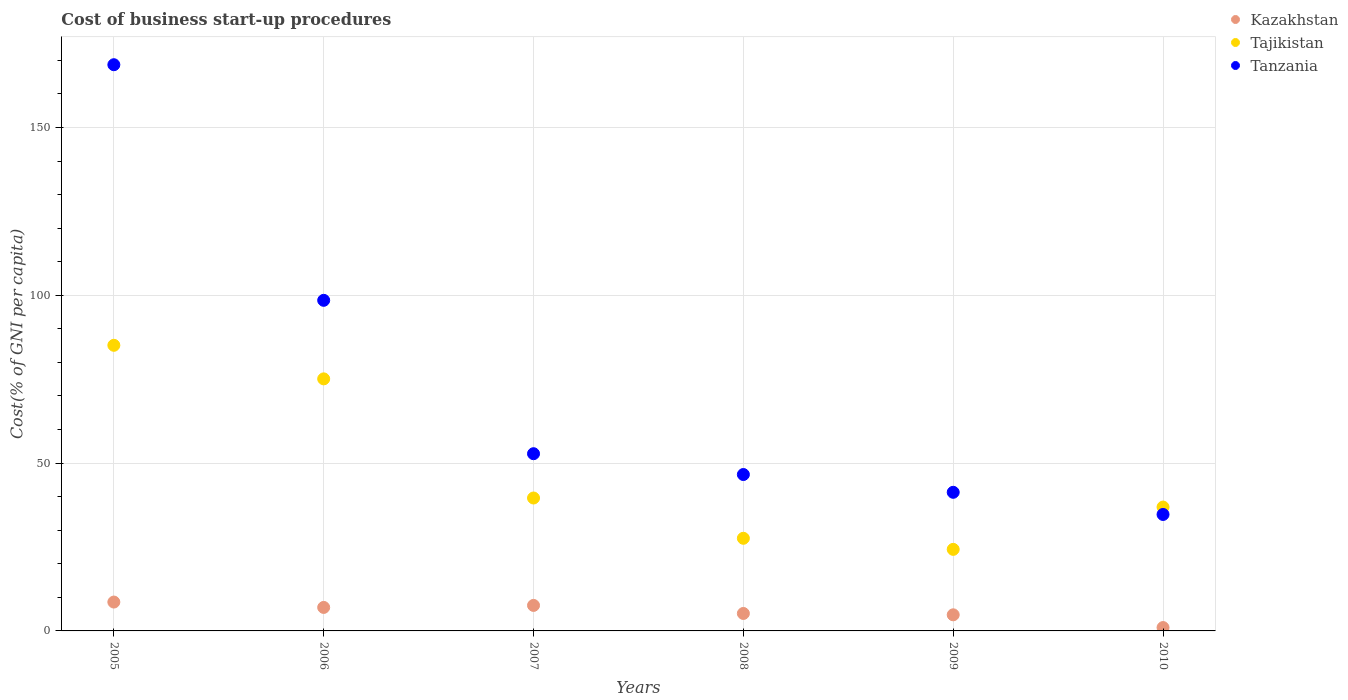Is the number of dotlines equal to the number of legend labels?
Ensure brevity in your answer.  Yes. What is the cost of business start-up procedures in Tajikistan in 2008?
Offer a very short reply. 27.6. Across all years, what is the maximum cost of business start-up procedures in Kazakhstan?
Keep it short and to the point. 8.6. Across all years, what is the minimum cost of business start-up procedures in Kazakhstan?
Your answer should be very brief. 1. In which year was the cost of business start-up procedures in Tanzania maximum?
Provide a succinct answer. 2005. In which year was the cost of business start-up procedures in Kazakhstan minimum?
Offer a terse response. 2010. What is the total cost of business start-up procedures in Tajikistan in the graph?
Your response must be concise. 288.6. What is the difference between the cost of business start-up procedures in Tanzania in 2005 and that in 2007?
Make the answer very short. 115.9. What is the difference between the cost of business start-up procedures in Tanzania in 2006 and the cost of business start-up procedures in Kazakhstan in 2010?
Ensure brevity in your answer.  97.5. What is the average cost of business start-up procedures in Tajikistan per year?
Provide a succinct answer. 48.1. In the year 2006, what is the difference between the cost of business start-up procedures in Tanzania and cost of business start-up procedures in Tajikistan?
Make the answer very short. 23.4. In how many years, is the cost of business start-up procedures in Kazakhstan greater than 50 %?
Your answer should be compact. 0. Is the cost of business start-up procedures in Tajikistan in 2006 less than that in 2009?
Your response must be concise. No. What is the difference between the highest and the second highest cost of business start-up procedures in Tanzania?
Your answer should be compact. 70.2. What is the difference between the highest and the lowest cost of business start-up procedures in Tanzania?
Your response must be concise. 134. Is the sum of the cost of business start-up procedures in Tajikistan in 2008 and 2009 greater than the maximum cost of business start-up procedures in Kazakhstan across all years?
Your answer should be compact. Yes. Is it the case that in every year, the sum of the cost of business start-up procedures in Kazakhstan and cost of business start-up procedures in Tanzania  is greater than the cost of business start-up procedures in Tajikistan?
Make the answer very short. No. Does the cost of business start-up procedures in Tanzania monotonically increase over the years?
Your response must be concise. No. Is the cost of business start-up procedures in Tajikistan strictly less than the cost of business start-up procedures in Tanzania over the years?
Provide a short and direct response. No. How many years are there in the graph?
Offer a very short reply. 6. Does the graph contain grids?
Make the answer very short. Yes. Where does the legend appear in the graph?
Make the answer very short. Top right. How many legend labels are there?
Make the answer very short. 3. How are the legend labels stacked?
Keep it short and to the point. Vertical. What is the title of the graph?
Make the answer very short. Cost of business start-up procedures. Does "East Asia (all income levels)" appear as one of the legend labels in the graph?
Your response must be concise. No. What is the label or title of the X-axis?
Give a very brief answer. Years. What is the label or title of the Y-axis?
Ensure brevity in your answer.  Cost(% of GNI per capita). What is the Cost(% of GNI per capita) of Tajikistan in 2005?
Make the answer very short. 85.1. What is the Cost(% of GNI per capita) of Tanzania in 2005?
Your answer should be very brief. 168.7. What is the Cost(% of GNI per capita) of Kazakhstan in 2006?
Your answer should be compact. 7. What is the Cost(% of GNI per capita) of Tajikistan in 2006?
Make the answer very short. 75.1. What is the Cost(% of GNI per capita) of Tanzania in 2006?
Keep it short and to the point. 98.5. What is the Cost(% of GNI per capita) in Kazakhstan in 2007?
Offer a terse response. 7.6. What is the Cost(% of GNI per capita) of Tajikistan in 2007?
Your response must be concise. 39.6. What is the Cost(% of GNI per capita) in Tanzania in 2007?
Provide a short and direct response. 52.8. What is the Cost(% of GNI per capita) in Kazakhstan in 2008?
Your answer should be very brief. 5.2. What is the Cost(% of GNI per capita) of Tajikistan in 2008?
Give a very brief answer. 27.6. What is the Cost(% of GNI per capita) in Tanzania in 2008?
Offer a very short reply. 46.6. What is the Cost(% of GNI per capita) in Tajikistan in 2009?
Offer a very short reply. 24.3. What is the Cost(% of GNI per capita) in Tanzania in 2009?
Keep it short and to the point. 41.3. What is the Cost(% of GNI per capita) of Tajikistan in 2010?
Offer a very short reply. 36.9. What is the Cost(% of GNI per capita) of Tanzania in 2010?
Provide a short and direct response. 34.7. Across all years, what is the maximum Cost(% of GNI per capita) of Tajikistan?
Keep it short and to the point. 85.1. Across all years, what is the maximum Cost(% of GNI per capita) of Tanzania?
Your response must be concise. 168.7. Across all years, what is the minimum Cost(% of GNI per capita) of Kazakhstan?
Provide a short and direct response. 1. Across all years, what is the minimum Cost(% of GNI per capita) of Tajikistan?
Provide a succinct answer. 24.3. Across all years, what is the minimum Cost(% of GNI per capita) of Tanzania?
Ensure brevity in your answer.  34.7. What is the total Cost(% of GNI per capita) of Kazakhstan in the graph?
Provide a short and direct response. 34.2. What is the total Cost(% of GNI per capita) of Tajikistan in the graph?
Ensure brevity in your answer.  288.6. What is the total Cost(% of GNI per capita) in Tanzania in the graph?
Ensure brevity in your answer.  442.6. What is the difference between the Cost(% of GNI per capita) of Tajikistan in 2005 and that in 2006?
Give a very brief answer. 10. What is the difference between the Cost(% of GNI per capita) in Tanzania in 2005 and that in 2006?
Provide a succinct answer. 70.2. What is the difference between the Cost(% of GNI per capita) in Tajikistan in 2005 and that in 2007?
Give a very brief answer. 45.5. What is the difference between the Cost(% of GNI per capita) of Tanzania in 2005 and that in 2007?
Provide a short and direct response. 115.9. What is the difference between the Cost(% of GNI per capita) in Kazakhstan in 2005 and that in 2008?
Keep it short and to the point. 3.4. What is the difference between the Cost(% of GNI per capita) of Tajikistan in 2005 and that in 2008?
Your answer should be very brief. 57.5. What is the difference between the Cost(% of GNI per capita) in Tanzania in 2005 and that in 2008?
Your answer should be very brief. 122.1. What is the difference between the Cost(% of GNI per capita) of Kazakhstan in 2005 and that in 2009?
Provide a short and direct response. 3.8. What is the difference between the Cost(% of GNI per capita) in Tajikistan in 2005 and that in 2009?
Provide a short and direct response. 60.8. What is the difference between the Cost(% of GNI per capita) of Tanzania in 2005 and that in 2009?
Your response must be concise. 127.4. What is the difference between the Cost(% of GNI per capita) in Kazakhstan in 2005 and that in 2010?
Your answer should be very brief. 7.6. What is the difference between the Cost(% of GNI per capita) in Tajikistan in 2005 and that in 2010?
Provide a short and direct response. 48.2. What is the difference between the Cost(% of GNI per capita) in Tanzania in 2005 and that in 2010?
Your answer should be very brief. 134. What is the difference between the Cost(% of GNI per capita) in Kazakhstan in 2006 and that in 2007?
Your answer should be very brief. -0.6. What is the difference between the Cost(% of GNI per capita) in Tajikistan in 2006 and that in 2007?
Your answer should be very brief. 35.5. What is the difference between the Cost(% of GNI per capita) of Tanzania in 2006 and that in 2007?
Offer a terse response. 45.7. What is the difference between the Cost(% of GNI per capita) in Kazakhstan in 2006 and that in 2008?
Your answer should be compact. 1.8. What is the difference between the Cost(% of GNI per capita) in Tajikistan in 2006 and that in 2008?
Your answer should be very brief. 47.5. What is the difference between the Cost(% of GNI per capita) in Tanzania in 2006 and that in 2008?
Keep it short and to the point. 51.9. What is the difference between the Cost(% of GNI per capita) of Kazakhstan in 2006 and that in 2009?
Offer a terse response. 2.2. What is the difference between the Cost(% of GNI per capita) in Tajikistan in 2006 and that in 2009?
Offer a very short reply. 50.8. What is the difference between the Cost(% of GNI per capita) in Tanzania in 2006 and that in 2009?
Keep it short and to the point. 57.2. What is the difference between the Cost(% of GNI per capita) of Tajikistan in 2006 and that in 2010?
Your response must be concise. 38.2. What is the difference between the Cost(% of GNI per capita) of Tanzania in 2006 and that in 2010?
Your response must be concise. 63.8. What is the difference between the Cost(% of GNI per capita) in Tajikistan in 2007 and that in 2008?
Keep it short and to the point. 12. What is the difference between the Cost(% of GNI per capita) of Tanzania in 2007 and that in 2008?
Offer a very short reply. 6.2. What is the difference between the Cost(% of GNI per capita) in Kazakhstan in 2007 and that in 2009?
Provide a short and direct response. 2.8. What is the difference between the Cost(% of GNI per capita) of Tajikistan in 2007 and that in 2009?
Make the answer very short. 15.3. What is the difference between the Cost(% of GNI per capita) of Tanzania in 2007 and that in 2010?
Offer a very short reply. 18.1. What is the difference between the Cost(% of GNI per capita) in Kazakhstan in 2008 and that in 2009?
Offer a very short reply. 0.4. What is the difference between the Cost(% of GNI per capita) of Tanzania in 2008 and that in 2009?
Ensure brevity in your answer.  5.3. What is the difference between the Cost(% of GNI per capita) in Kazakhstan in 2008 and that in 2010?
Offer a terse response. 4.2. What is the difference between the Cost(% of GNI per capita) in Tanzania in 2008 and that in 2010?
Give a very brief answer. 11.9. What is the difference between the Cost(% of GNI per capita) of Tajikistan in 2009 and that in 2010?
Provide a succinct answer. -12.6. What is the difference between the Cost(% of GNI per capita) of Tanzania in 2009 and that in 2010?
Offer a very short reply. 6.6. What is the difference between the Cost(% of GNI per capita) in Kazakhstan in 2005 and the Cost(% of GNI per capita) in Tajikistan in 2006?
Ensure brevity in your answer.  -66.5. What is the difference between the Cost(% of GNI per capita) in Kazakhstan in 2005 and the Cost(% of GNI per capita) in Tanzania in 2006?
Provide a succinct answer. -89.9. What is the difference between the Cost(% of GNI per capita) in Tajikistan in 2005 and the Cost(% of GNI per capita) in Tanzania in 2006?
Your answer should be very brief. -13.4. What is the difference between the Cost(% of GNI per capita) in Kazakhstan in 2005 and the Cost(% of GNI per capita) in Tajikistan in 2007?
Offer a very short reply. -31. What is the difference between the Cost(% of GNI per capita) in Kazakhstan in 2005 and the Cost(% of GNI per capita) in Tanzania in 2007?
Provide a short and direct response. -44.2. What is the difference between the Cost(% of GNI per capita) of Tajikistan in 2005 and the Cost(% of GNI per capita) of Tanzania in 2007?
Your answer should be very brief. 32.3. What is the difference between the Cost(% of GNI per capita) of Kazakhstan in 2005 and the Cost(% of GNI per capita) of Tajikistan in 2008?
Your answer should be very brief. -19. What is the difference between the Cost(% of GNI per capita) of Kazakhstan in 2005 and the Cost(% of GNI per capita) of Tanzania in 2008?
Keep it short and to the point. -38. What is the difference between the Cost(% of GNI per capita) of Tajikistan in 2005 and the Cost(% of GNI per capita) of Tanzania in 2008?
Give a very brief answer. 38.5. What is the difference between the Cost(% of GNI per capita) of Kazakhstan in 2005 and the Cost(% of GNI per capita) of Tajikistan in 2009?
Your answer should be very brief. -15.7. What is the difference between the Cost(% of GNI per capita) of Kazakhstan in 2005 and the Cost(% of GNI per capita) of Tanzania in 2009?
Your answer should be compact. -32.7. What is the difference between the Cost(% of GNI per capita) in Tajikistan in 2005 and the Cost(% of GNI per capita) in Tanzania in 2009?
Offer a terse response. 43.8. What is the difference between the Cost(% of GNI per capita) of Kazakhstan in 2005 and the Cost(% of GNI per capita) of Tajikistan in 2010?
Provide a short and direct response. -28.3. What is the difference between the Cost(% of GNI per capita) of Kazakhstan in 2005 and the Cost(% of GNI per capita) of Tanzania in 2010?
Keep it short and to the point. -26.1. What is the difference between the Cost(% of GNI per capita) of Tajikistan in 2005 and the Cost(% of GNI per capita) of Tanzania in 2010?
Your response must be concise. 50.4. What is the difference between the Cost(% of GNI per capita) of Kazakhstan in 2006 and the Cost(% of GNI per capita) of Tajikistan in 2007?
Provide a short and direct response. -32.6. What is the difference between the Cost(% of GNI per capita) of Kazakhstan in 2006 and the Cost(% of GNI per capita) of Tanzania in 2007?
Give a very brief answer. -45.8. What is the difference between the Cost(% of GNI per capita) of Tajikistan in 2006 and the Cost(% of GNI per capita) of Tanzania in 2007?
Give a very brief answer. 22.3. What is the difference between the Cost(% of GNI per capita) of Kazakhstan in 2006 and the Cost(% of GNI per capita) of Tajikistan in 2008?
Ensure brevity in your answer.  -20.6. What is the difference between the Cost(% of GNI per capita) of Kazakhstan in 2006 and the Cost(% of GNI per capita) of Tanzania in 2008?
Give a very brief answer. -39.6. What is the difference between the Cost(% of GNI per capita) in Tajikistan in 2006 and the Cost(% of GNI per capita) in Tanzania in 2008?
Your answer should be very brief. 28.5. What is the difference between the Cost(% of GNI per capita) in Kazakhstan in 2006 and the Cost(% of GNI per capita) in Tajikistan in 2009?
Offer a very short reply. -17.3. What is the difference between the Cost(% of GNI per capita) in Kazakhstan in 2006 and the Cost(% of GNI per capita) in Tanzania in 2009?
Your response must be concise. -34.3. What is the difference between the Cost(% of GNI per capita) of Tajikistan in 2006 and the Cost(% of GNI per capita) of Tanzania in 2009?
Keep it short and to the point. 33.8. What is the difference between the Cost(% of GNI per capita) in Kazakhstan in 2006 and the Cost(% of GNI per capita) in Tajikistan in 2010?
Your response must be concise. -29.9. What is the difference between the Cost(% of GNI per capita) in Kazakhstan in 2006 and the Cost(% of GNI per capita) in Tanzania in 2010?
Ensure brevity in your answer.  -27.7. What is the difference between the Cost(% of GNI per capita) of Tajikistan in 2006 and the Cost(% of GNI per capita) of Tanzania in 2010?
Provide a short and direct response. 40.4. What is the difference between the Cost(% of GNI per capita) in Kazakhstan in 2007 and the Cost(% of GNI per capita) in Tajikistan in 2008?
Provide a succinct answer. -20. What is the difference between the Cost(% of GNI per capita) in Kazakhstan in 2007 and the Cost(% of GNI per capita) in Tanzania in 2008?
Your response must be concise. -39. What is the difference between the Cost(% of GNI per capita) in Kazakhstan in 2007 and the Cost(% of GNI per capita) in Tajikistan in 2009?
Your answer should be very brief. -16.7. What is the difference between the Cost(% of GNI per capita) of Kazakhstan in 2007 and the Cost(% of GNI per capita) of Tanzania in 2009?
Give a very brief answer. -33.7. What is the difference between the Cost(% of GNI per capita) in Tajikistan in 2007 and the Cost(% of GNI per capita) in Tanzania in 2009?
Your response must be concise. -1.7. What is the difference between the Cost(% of GNI per capita) of Kazakhstan in 2007 and the Cost(% of GNI per capita) of Tajikistan in 2010?
Keep it short and to the point. -29.3. What is the difference between the Cost(% of GNI per capita) of Kazakhstan in 2007 and the Cost(% of GNI per capita) of Tanzania in 2010?
Keep it short and to the point. -27.1. What is the difference between the Cost(% of GNI per capita) of Tajikistan in 2007 and the Cost(% of GNI per capita) of Tanzania in 2010?
Make the answer very short. 4.9. What is the difference between the Cost(% of GNI per capita) in Kazakhstan in 2008 and the Cost(% of GNI per capita) in Tajikistan in 2009?
Your answer should be compact. -19.1. What is the difference between the Cost(% of GNI per capita) of Kazakhstan in 2008 and the Cost(% of GNI per capita) of Tanzania in 2009?
Your answer should be very brief. -36.1. What is the difference between the Cost(% of GNI per capita) in Tajikistan in 2008 and the Cost(% of GNI per capita) in Tanzania in 2009?
Offer a terse response. -13.7. What is the difference between the Cost(% of GNI per capita) in Kazakhstan in 2008 and the Cost(% of GNI per capita) in Tajikistan in 2010?
Ensure brevity in your answer.  -31.7. What is the difference between the Cost(% of GNI per capita) in Kazakhstan in 2008 and the Cost(% of GNI per capita) in Tanzania in 2010?
Offer a terse response. -29.5. What is the difference between the Cost(% of GNI per capita) in Kazakhstan in 2009 and the Cost(% of GNI per capita) in Tajikistan in 2010?
Ensure brevity in your answer.  -32.1. What is the difference between the Cost(% of GNI per capita) of Kazakhstan in 2009 and the Cost(% of GNI per capita) of Tanzania in 2010?
Give a very brief answer. -29.9. What is the difference between the Cost(% of GNI per capita) of Tajikistan in 2009 and the Cost(% of GNI per capita) of Tanzania in 2010?
Your answer should be compact. -10.4. What is the average Cost(% of GNI per capita) in Kazakhstan per year?
Ensure brevity in your answer.  5.7. What is the average Cost(% of GNI per capita) of Tajikistan per year?
Provide a short and direct response. 48.1. What is the average Cost(% of GNI per capita) of Tanzania per year?
Ensure brevity in your answer.  73.77. In the year 2005, what is the difference between the Cost(% of GNI per capita) of Kazakhstan and Cost(% of GNI per capita) of Tajikistan?
Your answer should be compact. -76.5. In the year 2005, what is the difference between the Cost(% of GNI per capita) in Kazakhstan and Cost(% of GNI per capita) in Tanzania?
Keep it short and to the point. -160.1. In the year 2005, what is the difference between the Cost(% of GNI per capita) of Tajikistan and Cost(% of GNI per capita) of Tanzania?
Offer a very short reply. -83.6. In the year 2006, what is the difference between the Cost(% of GNI per capita) in Kazakhstan and Cost(% of GNI per capita) in Tajikistan?
Offer a terse response. -68.1. In the year 2006, what is the difference between the Cost(% of GNI per capita) of Kazakhstan and Cost(% of GNI per capita) of Tanzania?
Your answer should be compact. -91.5. In the year 2006, what is the difference between the Cost(% of GNI per capita) in Tajikistan and Cost(% of GNI per capita) in Tanzania?
Make the answer very short. -23.4. In the year 2007, what is the difference between the Cost(% of GNI per capita) of Kazakhstan and Cost(% of GNI per capita) of Tajikistan?
Your answer should be compact. -32. In the year 2007, what is the difference between the Cost(% of GNI per capita) in Kazakhstan and Cost(% of GNI per capita) in Tanzania?
Keep it short and to the point. -45.2. In the year 2007, what is the difference between the Cost(% of GNI per capita) in Tajikistan and Cost(% of GNI per capita) in Tanzania?
Your answer should be compact. -13.2. In the year 2008, what is the difference between the Cost(% of GNI per capita) in Kazakhstan and Cost(% of GNI per capita) in Tajikistan?
Keep it short and to the point. -22.4. In the year 2008, what is the difference between the Cost(% of GNI per capita) in Kazakhstan and Cost(% of GNI per capita) in Tanzania?
Provide a short and direct response. -41.4. In the year 2008, what is the difference between the Cost(% of GNI per capita) of Tajikistan and Cost(% of GNI per capita) of Tanzania?
Provide a succinct answer. -19. In the year 2009, what is the difference between the Cost(% of GNI per capita) in Kazakhstan and Cost(% of GNI per capita) in Tajikistan?
Your response must be concise. -19.5. In the year 2009, what is the difference between the Cost(% of GNI per capita) of Kazakhstan and Cost(% of GNI per capita) of Tanzania?
Keep it short and to the point. -36.5. In the year 2010, what is the difference between the Cost(% of GNI per capita) of Kazakhstan and Cost(% of GNI per capita) of Tajikistan?
Ensure brevity in your answer.  -35.9. In the year 2010, what is the difference between the Cost(% of GNI per capita) of Kazakhstan and Cost(% of GNI per capita) of Tanzania?
Your response must be concise. -33.7. What is the ratio of the Cost(% of GNI per capita) in Kazakhstan in 2005 to that in 2006?
Make the answer very short. 1.23. What is the ratio of the Cost(% of GNI per capita) in Tajikistan in 2005 to that in 2006?
Your response must be concise. 1.13. What is the ratio of the Cost(% of GNI per capita) of Tanzania in 2005 to that in 2006?
Your response must be concise. 1.71. What is the ratio of the Cost(% of GNI per capita) of Kazakhstan in 2005 to that in 2007?
Make the answer very short. 1.13. What is the ratio of the Cost(% of GNI per capita) in Tajikistan in 2005 to that in 2007?
Offer a very short reply. 2.15. What is the ratio of the Cost(% of GNI per capita) in Tanzania in 2005 to that in 2007?
Your response must be concise. 3.2. What is the ratio of the Cost(% of GNI per capita) in Kazakhstan in 2005 to that in 2008?
Your answer should be very brief. 1.65. What is the ratio of the Cost(% of GNI per capita) of Tajikistan in 2005 to that in 2008?
Offer a very short reply. 3.08. What is the ratio of the Cost(% of GNI per capita) in Tanzania in 2005 to that in 2008?
Provide a short and direct response. 3.62. What is the ratio of the Cost(% of GNI per capita) of Kazakhstan in 2005 to that in 2009?
Make the answer very short. 1.79. What is the ratio of the Cost(% of GNI per capita) in Tajikistan in 2005 to that in 2009?
Provide a short and direct response. 3.5. What is the ratio of the Cost(% of GNI per capita) in Tanzania in 2005 to that in 2009?
Keep it short and to the point. 4.08. What is the ratio of the Cost(% of GNI per capita) in Kazakhstan in 2005 to that in 2010?
Your answer should be very brief. 8.6. What is the ratio of the Cost(% of GNI per capita) of Tajikistan in 2005 to that in 2010?
Make the answer very short. 2.31. What is the ratio of the Cost(% of GNI per capita) of Tanzania in 2005 to that in 2010?
Provide a short and direct response. 4.86. What is the ratio of the Cost(% of GNI per capita) of Kazakhstan in 2006 to that in 2007?
Your response must be concise. 0.92. What is the ratio of the Cost(% of GNI per capita) in Tajikistan in 2006 to that in 2007?
Ensure brevity in your answer.  1.9. What is the ratio of the Cost(% of GNI per capita) in Tanzania in 2006 to that in 2007?
Make the answer very short. 1.87. What is the ratio of the Cost(% of GNI per capita) in Kazakhstan in 2006 to that in 2008?
Offer a very short reply. 1.35. What is the ratio of the Cost(% of GNI per capita) in Tajikistan in 2006 to that in 2008?
Your answer should be compact. 2.72. What is the ratio of the Cost(% of GNI per capita) of Tanzania in 2006 to that in 2008?
Your answer should be very brief. 2.11. What is the ratio of the Cost(% of GNI per capita) in Kazakhstan in 2006 to that in 2009?
Provide a succinct answer. 1.46. What is the ratio of the Cost(% of GNI per capita) in Tajikistan in 2006 to that in 2009?
Your answer should be compact. 3.09. What is the ratio of the Cost(% of GNI per capita) in Tanzania in 2006 to that in 2009?
Provide a succinct answer. 2.38. What is the ratio of the Cost(% of GNI per capita) of Kazakhstan in 2006 to that in 2010?
Your response must be concise. 7. What is the ratio of the Cost(% of GNI per capita) in Tajikistan in 2006 to that in 2010?
Your response must be concise. 2.04. What is the ratio of the Cost(% of GNI per capita) of Tanzania in 2006 to that in 2010?
Offer a very short reply. 2.84. What is the ratio of the Cost(% of GNI per capita) in Kazakhstan in 2007 to that in 2008?
Offer a very short reply. 1.46. What is the ratio of the Cost(% of GNI per capita) in Tajikistan in 2007 to that in 2008?
Your response must be concise. 1.43. What is the ratio of the Cost(% of GNI per capita) of Tanzania in 2007 to that in 2008?
Offer a terse response. 1.13. What is the ratio of the Cost(% of GNI per capita) of Kazakhstan in 2007 to that in 2009?
Provide a short and direct response. 1.58. What is the ratio of the Cost(% of GNI per capita) of Tajikistan in 2007 to that in 2009?
Offer a terse response. 1.63. What is the ratio of the Cost(% of GNI per capita) of Tanzania in 2007 to that in 2009?
Make the answer very short. 1.28. What is the ratio of the Cost(% of GNI per capita) in Kazakhstan in 2007 to that in 2010?
Ensure brevity in your answer.  7.6. What is the ratio of the Cost(% of GNI per capita) in Tajikistan in 2007 to that in 2010?
Your answer should be very brief. 1.07. What is the ratio of the Cost(% of GNI per capita) in Tanzania in 2007 to that in 2010?
Offer a terse response. 1.52. What is the ratio of the Cost(% of GNI per capita) of Kazakhstan in 2008 to that in 2009?
Your answer should be compact. 1.08. What is the ratio of the Cost(% of GNI per capita) in Tajikistan in 2008 to that in 2009?
Give a very brief answer. 1.14. What is the ratio of the Cost(% of GNI per capita) of Tanzania in 2008 to that in 2009?
Provide a short and direct response. 1.13. What is the ratio of the Cost(% of GNI per capita) of Kazakhstan in 2008 to that in 2010?
Your answer should be compact. 5.2. What is the ratio of the Cost(% of GNI per capita) of Tajikistan in 2008 to that in 2010?
Your response must be concise. 0.75. What is the ratio of the Cost(% of GNI per capita) of Tanzania in 2008 to that in 2010?
Offer a very short reply. 1.34. What is the ratio of the Cost(% of GNI per capita) in Tajikistan in 2009 to that in 2010?
Give a very brief answer. 0.66. What is the ratio of the Cost(% of GNI per capita) in Tanzania in 2009 to that in 2010?
Offer a terse response. 1.19. What is the difference between the highest and the second highest Cost(% of GNI per capita) in Kazakhstan?
Provide a short and direct response. 1. What is the difference between the highest and the second highest Cost(% of GNI per capita) of Tajikistan?
Keep it short and to the point. 10. What is the difference between the highest and the second highest Cost(% of GNI per capita) in Tanzania?
Provide a succinct answer. 70.2. What is the difference between the highest and the lowest Cost(% of GNI per capita) of Tajikistan?
Offer a very short reply. 60.8. What is the difference between the highest and the lowest Cost(% of GNI per capita) in Tanzania?
Your answer should be compact. 134. 